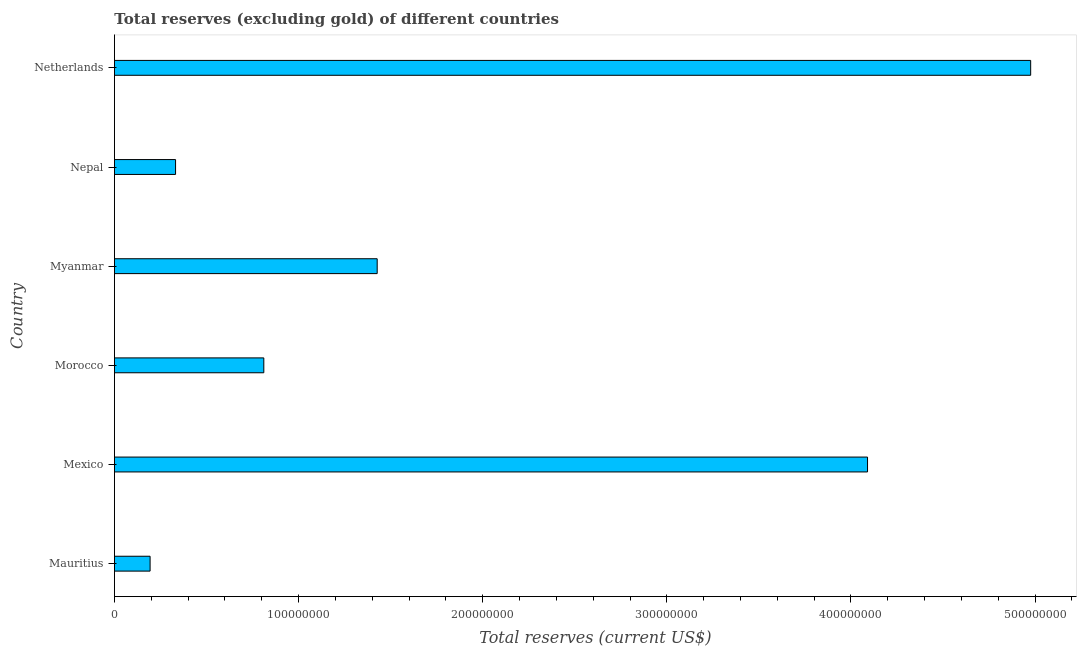Does the graph contain any zero values?
Provide a short and direct response. No. What is the title of the graph?
Keep it short and to the point. Total reserves (excluding gold) of different countries. What is the label or title of the X-axis?
Offer a very short reply. Total reserves (current US$). What is the label or title of the Y-axis?
Provide a short and direct response. Country. What is the total reserves (excluding gold) in Myanmar?
Provide a succinct answer. 1.43e+08. Across all countries, what is the maximum total reserves (excluding gold)?
Give a very brief answer. 4.98e+08. Across all countries, what is the minimum total reserves (excluding gold)?
Your answer should be very brief. 1.94e+07. In which country was the total reserves (excluding gold) maximum?
Your response must be concise. Netherlands. In which country was the total reserves (excluding gold) minimum?
Offer a terse response. Mauritius. What is the sum of the total reserves (excluding gold)?
Your response must be concise. 1.18e+09. What is the difference between the total reserves (excluding gold) in Morocco and Nepal?
Give a very brief answer. 4.79e+07. What is the average total reserves (excluding gold) per country?
Provide a short and direct response. 1.97e+08. What is the median total reserves (excluding gold)?
Provide a short and direct response. 1.12e+08. What is the ratio of the total reserves (excluding gold) in Mauritius to that in Morocco?
Your response must be concise. 0.24. What is the difference between the highest and the second highest total reserves (excluding gold)?
Your answer should be very brief. 8.86e+07. Is the sum of the total reserves (excluding gold) in Mexico and Myanmar greater than the maximum total reserves (excluding gold) across all countries?
Your answer should be compact. Yes. What is the difference between the highest and the lowest total reserves (excluding gold)?
Your response must be concise. 4.78e+08. In how many countries, is the total reserves (excluding gold) greater than the average total reserves (excluding gold) taken over all countries?
Keep it short and to the point. 2. How many bars are there?
Your answer should be very brief. 6. Are all the bars in the graph horizontal?
Your response must be concise. Yes. How many countries are there in the graph?
Your answer should be compact. 6. What is the difference between two consecutive major ticks on the X-axis?
Keep it short and to the point. 1.00e+08. What is the Total reserves (current US$) of Mauritius?
Keep it short and to the point. 1.94e+07. What is the Total reserves (current US$) in Mexico?
Ensure brevity in your answer.  4.09e+08. What is the Total reserves (current US$) of Morocco?
Give a very brief answer. 8.11e+07. What is the Total reserves (current US$) in Myanmar?
Offer a very short reply. 1.43e+08. What is the Total reserves (current US$) of Nepal?
Your answer should be compact. 3.32e+07. What is the Total reserves (current US$) in Netherlands?
Make the answer very short. 4.98e+08. What is the difference between the Total reserves (current US$) in Mauritius and Mexico?
Provide a short and direct response. -3.90e+08. What is the difference between the Total reserves (current US$) in Mauritius and Morocco?
Your response must be concise. -6.18e+07. What is the difference between the Total reserves (current US$) in Mauritius and Myanmar?
Your response must be concise. -1.23e+08. What is the difference between the Total reserves (current US$) in Mauritius and Nepal?
Ensure brevity in your answer.  -1.38e+07. What is the difference between the Total reserves (current US$) in Mauritius and Netherlands?
Ensure brevity in your answer.  -4.78e+08. What is the difference between the Total reserves (current US$) in Mexico and Morocco?
Your response must be concise. 3.28e+08. What is the difference between the Total reserves (current US$) in Mexico and Myanmar?
Provide a short and direct response. 2.66e+08. What is the difference between the Total reserves (current US$) in Mexico and Nepal?
Provide a succinct answer. 3.76e+08. What is the difference between the Total reserves (current US$) in Mexico and Netherlands?
Offer a very short reply. -8.86e+07. What is the difference between the Total reserves (current US$) in Morocco and Myanmar?
Provide a succinct answer. -6.16e+07. What is the difference between the Total reserves (current US$) in Morocco and Nepal?
Your response must be concise. 4.79e+07. What is the difference between the Total reserves (current US$) in Morocco and Netherlands?
Give a very brief answer. -4.16e+08. What is the difference between the Total reserves (current US$) in Myanmar and Nepal?
Make the answer very short. 1.09e+08. What is the difference between the Total reserves (current US$) in Myanmar and Netherlands?
Offer a very short reply. -3.55e+08. What is the difference between the Total reserves (current US$) in Nepal and Netherlands?
Offer a terse response. -4.64e+08. What is the ratio of the Total reserves (current US$) in Mauritius to that in Mexico?
Your answer should be compact. 0.05. What is the ratio of the Total reserves (current US$) in Mauritius to that in Morocco?
Your response must be concise. 0.24. What is the ratio of the Total reserves (current US$) in Mauritius to that in Myanmar?
Provide a short and direct response. 0.14. What is the ratio of the Total reserves (current US$) in Mauritius to that in Nepal?
Provide a succinct answer. 0.58. What is the ratio of the Total reserves (current US$) in Mauritius to that in Netherlands?
Your response must be concise. 0.04. What is the ratio of the Total reserves (current US$) in Mexico to that in Morocco?
Keep it short and to the point. 5.04. What is the ratio of the Total reserves (current US$) in Mexico to that in Myanmar?
Provide a short and direct response. 2.87. What is the ratio of the Total reserves (current US$) in Mexico to that in Nepal?
Offer a very short reply. 12.32. What is the ratio of the Total reserves (current US$) in Mexico to that in Netherlands?
Provide a succinct answer. 0.82. What is the ratio of the Total reserves (current US$) in Morocco to that in Myanmar?
Your response must be concise. 0.57. What is the ratio of the Total reserves (current US$) in Morocco to that in Nepal?
Keep it short and to the point. 2.44. What is the ratio of the Total reserves (current US$) in Morocco to that in Netherlands?
Make the answer very short. 0.16. What is the ratio of the Total reserves (current US$) in Myanmar to that in Nepal?
Ensure brevity in your answer.  4.3. What is the ratio of the Total reserves (current US$) in Myanmar to that in Netherlands?
Give a very brief answer. 0.29. What is the ratio of the Total reserves (current US$) in Nepal to that in Netherlands?
Your answer should be very brief. 0.07. 